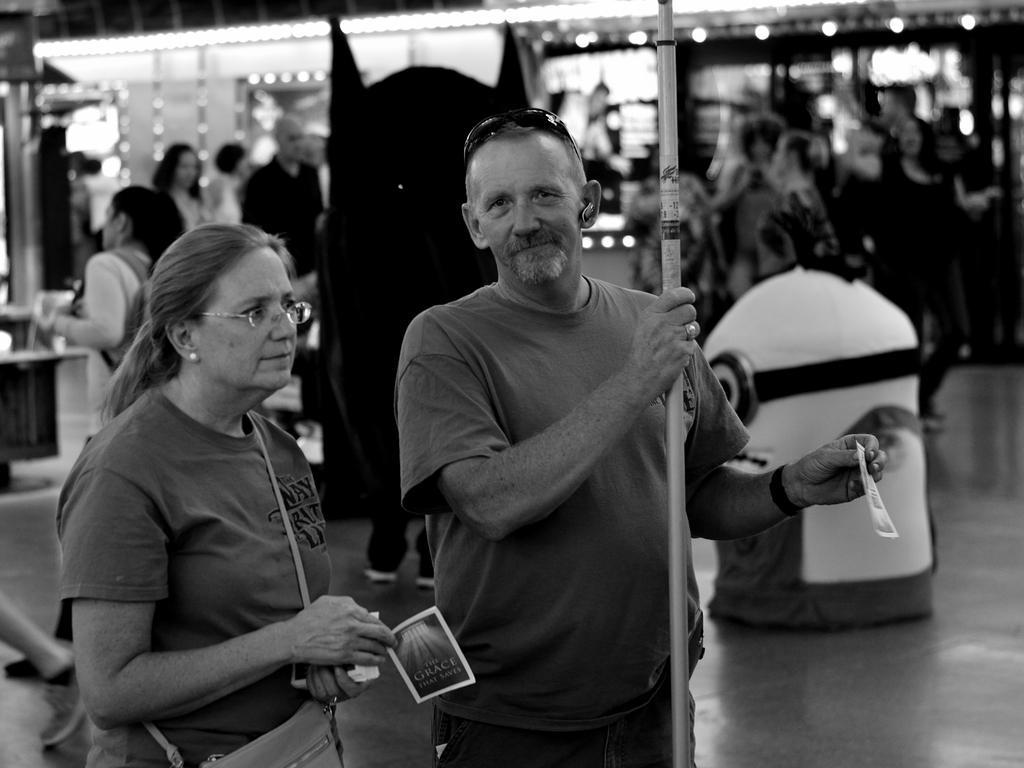Can you describe this image briefly? In this image we can see people and there is an object. There is a pole. In the background we can see lights. 